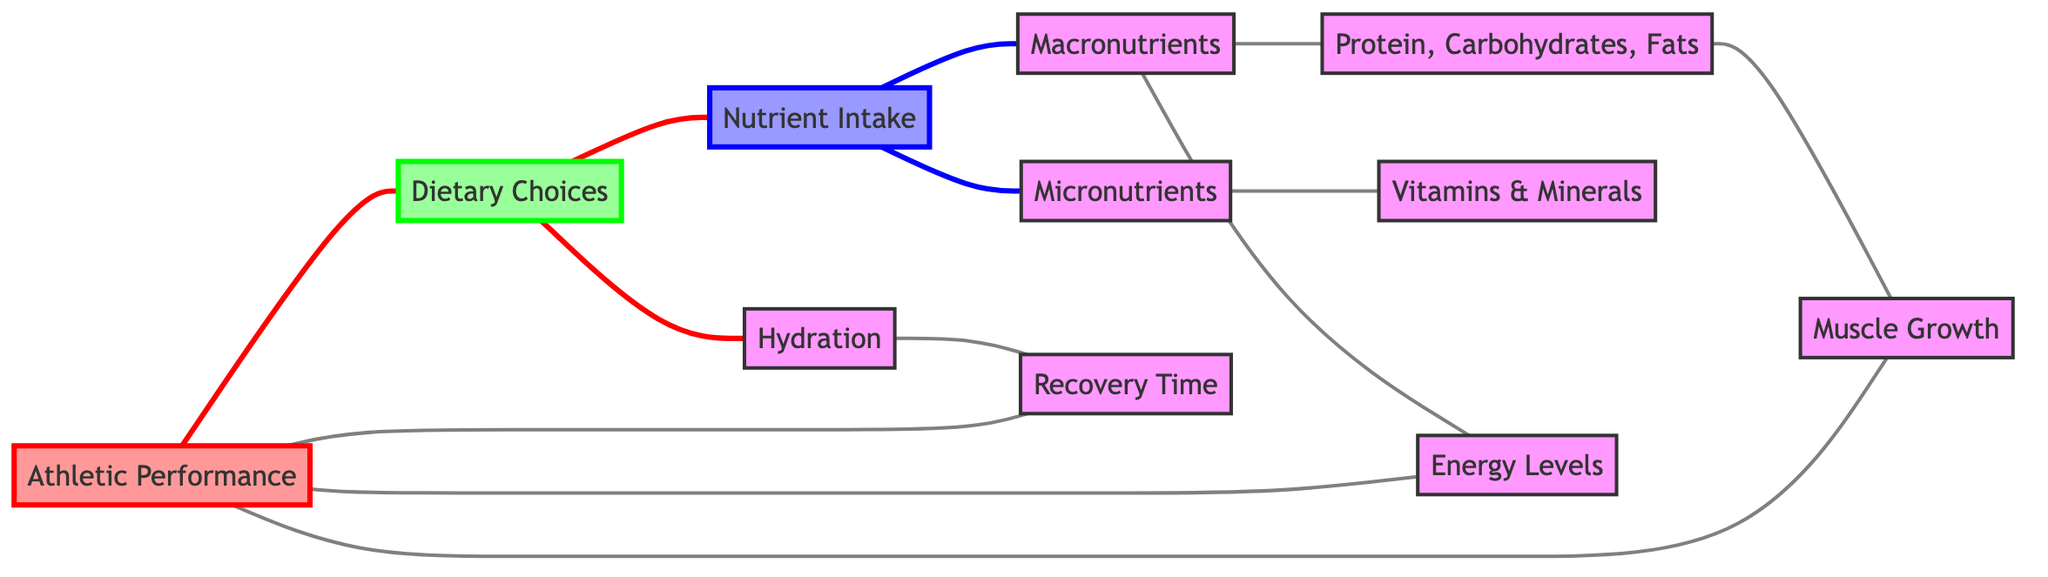What is the central node in this diagram? The central node connects directly to multiple nodes; in this case, "Athletic Performance" serves as the central node, linking to "Dietary Choices," "Muscle Growth," "Energy Levels," and "Recovery Time."
Answer: Athletic Performance How many nodes are in the diagram? By counting the listed nodes, we find there are 11 unique nodes: Athletic Performance, Dietary Choices, Nutrient Intake, Hydration, Macronutrients, Micronutrients, Protein, Carbohydrates, Fats, Vitamins, Minerals, Recovery Time, Energy Levels, and Muscle Growth.
Answer: 11 What nodes are directly connected to Dietary Choices? The direct connections of "Dietary Choices" include "Nutrient Intake" and "Hydration," as indicated by edges emanating from it to these two nodes.
Answer: Nutrient Intake, Hydration Which node is connected to both Nutrient Intake and Hydration? Analyzing the connections, "Dietary Choices" is the node that connects to both "Nutrient Intake" and "Hydration," as it directly links to both.
Answer: Dietary Choices How many edges connect to Athletic Performance? There are four direct connections to the node "Athletic Performance," which are from "Muscle Growth," "Energy Levels," "Recovery Time," and "Dietary Choices."
Answer: 4 How does Macronutrients affect Athletic Performance? "Macronutrients" has a direct connection to "Athletic Performance" through its influence on "Muscle Growth" and "Energy Levels," leading to enhanced performance.
Answer: Through Muscle Growth and Energy Levels Which nodes contribute to Recovery Time? Only one direct connection contributes to "Recovery Time," which is from "Hydration," indicating that adequate hydration affects recovery times.
Answer: Hydration What is the connection from Protein, Carbohydrates, and Fats to Athletic Performance? The connection is established through "Muscle Growth," which directly affects "Athletic Performance," indicating that proper macronutrient intake supports performance through muscle development.
Answer: Muscle Growth 